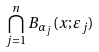<formula> <loc_0><loc_0><loc_500><loc_500>\bigcap _ { j = 1 } ^ { n } B _ { \alpha _ { j } } ( x ; \varepsilon _ { j } )</formula> 